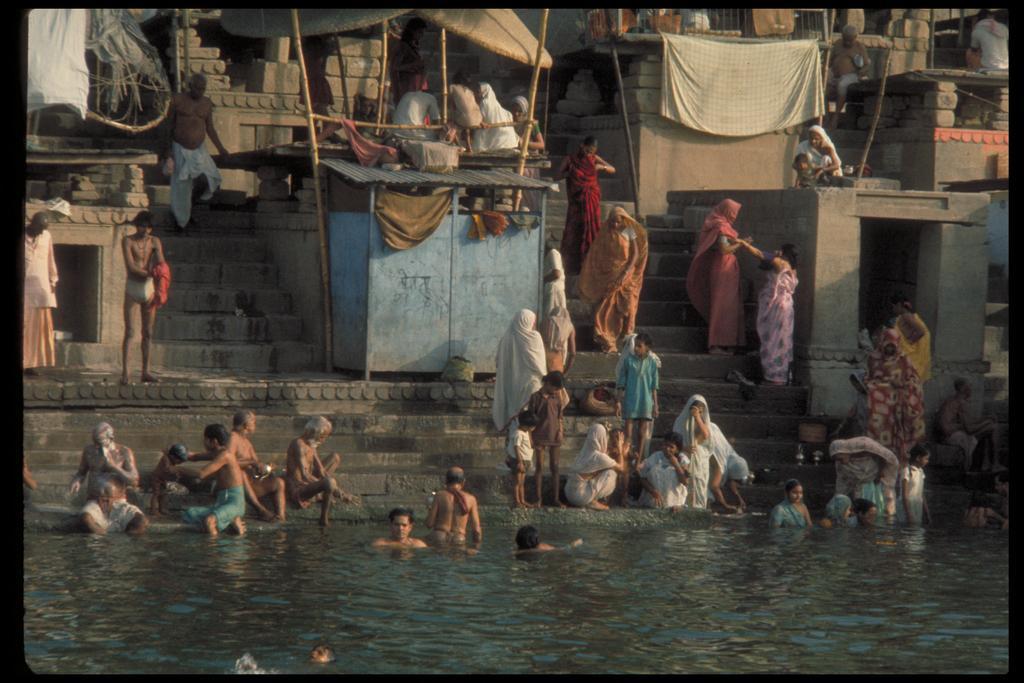Can you describe this image briefly? In the picture we can see the bank of the river with steps and some old constructions and some stalls and some people are sitting on the steps and some people are bathing in the river water. 